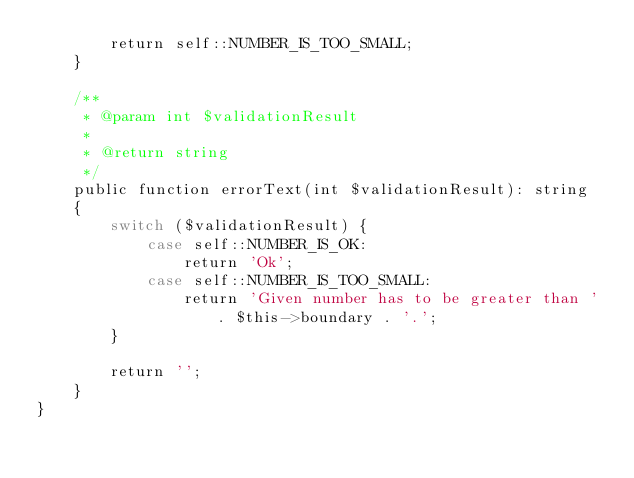Convert code to text. <code><loc_0><loc_0><loc_500><loc_500><_PHP_>		return self::NUMBER_IS_TOO_SMALL;
	}

	/**
	 * @param int $validationResult
	 *
	 * @return string
	 */
	public function errorText(int $validationResult): string
	{
		switch ($validationResult) {
			case self::NUMBER_IS_OK:
				return 'Ok';
			case self::NUMBER_IS_TOO_SMALL:
				return 'Given number has to be greater than ' . $this->boundary . '.';
		}

		return '';
	}
}
</code> 